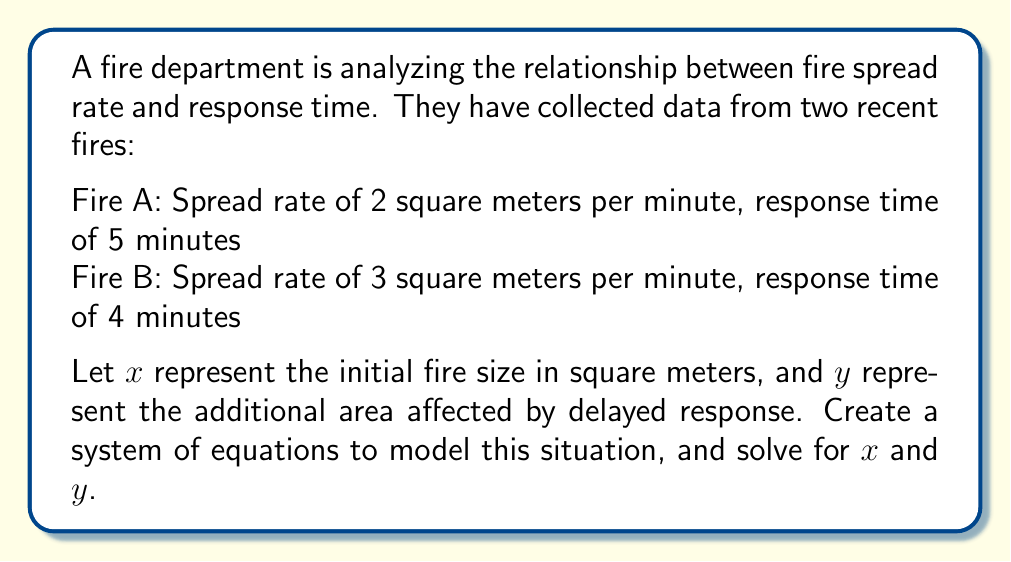Solve this math problem. Let's approach this step-by-step:

1) For each fire, we can create an equation in the form:
   Total area affected = Initial fire size + (Spread rate × Response time)

2) For Fire A:
   $x + 2 \cdot 5 = x + 10$

3) For Fire B:
   $x + 3 \cdot 4 = x + 12$

4) Now, let's incorporate $y$ to represent the additional area affected by delayed response:
   Fire A: $x + y = x + 10$
   Fire B: $x + y = x + 12$

5) This gives us our system of equations:
   $$\begin{cases}
   x + y = x + 10 \\
   x + y = x + 12
   \end{cases}$$

6) Simplify the equations:
   $$\begin{cases}
   y = 10 \\
   y = 12
   \end{cases}$$

7) These equations are inconsistent (no solution), which means our initial assumption about a constant initial fire size was incorrect.

8) Let's modify our approach. Instead of a constant initial size, let's use $x_A$ and $x_B$ for the initial sizes of Fire A and B respectively:
   $$\begin{cases}
   x_A + y = x_A + 10 \\
   x_B + y = x_B + 12
   \end{cases}$$

9) Simplify:
   $$\begin{cases}
   y = 10 \\
   y = 12
   \end{cases}$$

10) We can conclude that $y = 10$ for Fire A and $y = 12$ for Fire B.
Answer: $y_A = 10$, $y_B = 12$ 